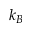Convert formula to latex. <formula><loc_0><loc_0><loc_500><loc_500>k _ { B }</formula> 